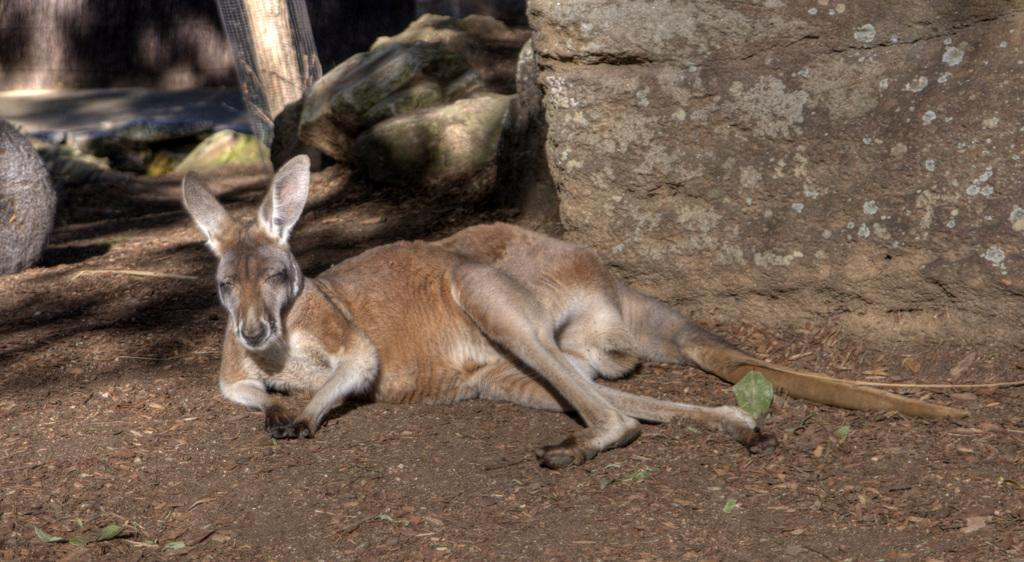What type of animal is in the image? There is a kangaroo in the image. What can be seen in the background of the image? There are rocks in the background of the image. What type of trees can be seen in the image? There are no trees present in the image; it features a kangaroo and rocks in the background. How does the kangaroo communicate with others in the image? The image does not show the kangaroo communicating with others, so it cannot be determined from the picture. 